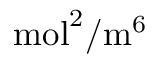Convert formula to latex. <formula><loc_0><loc_0><loc_500><loc_500>m o l ^ { 2 } / m ^ { 6 }</formula> 